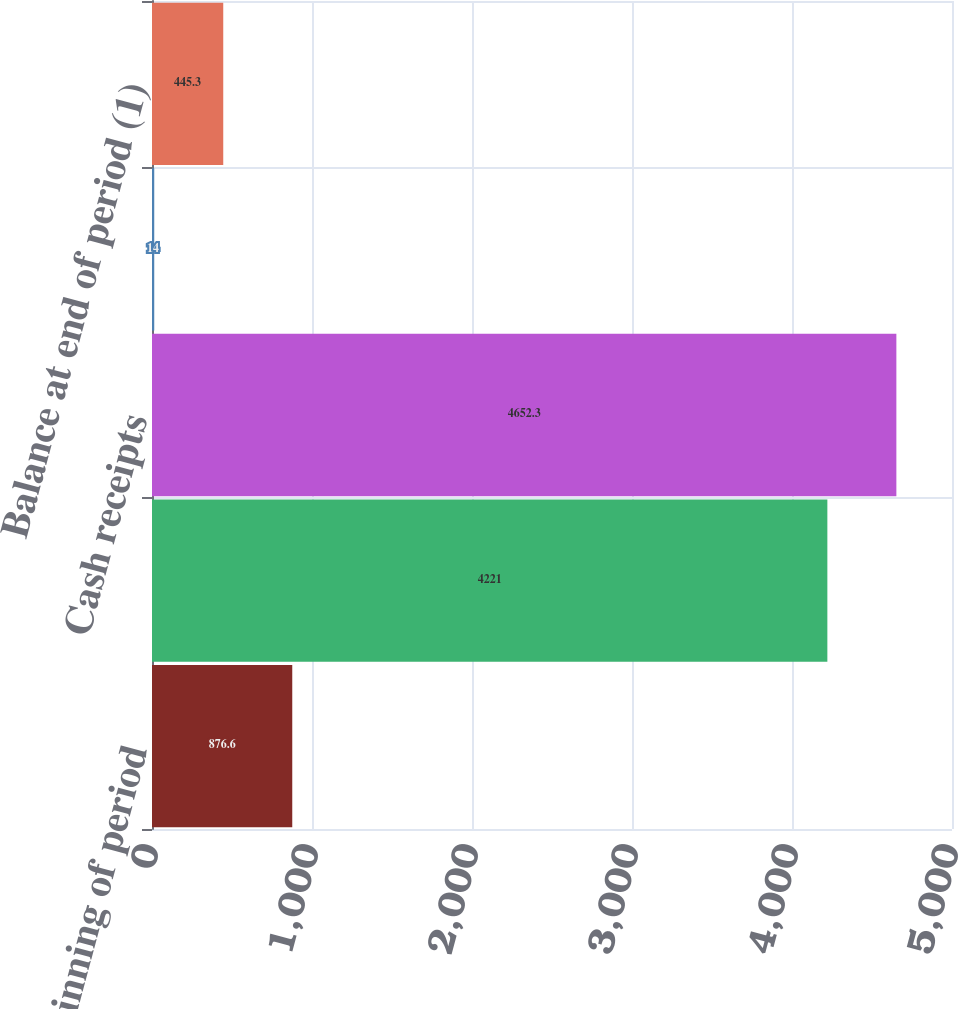<chart> <loc_0><loc_0><loc_500><loc_500><bar_chart><fcel>Balance at beginning of period<fcel>Trade receivables sold<fcel>Cash receipts<fcel>Foreign currency and other<fcel>Balance at end of period (1)<nl><fcel>876.6<fcel>4221<fcel>4652.3<fcel>14<fcel>445.3<nl></chart> 